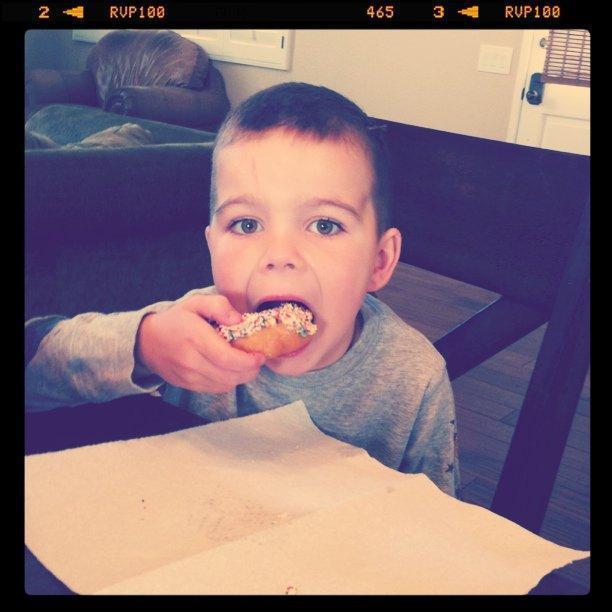Does the caption "The donut is touching the dining table." correctly depict the image?
Answer yes or no. No. 